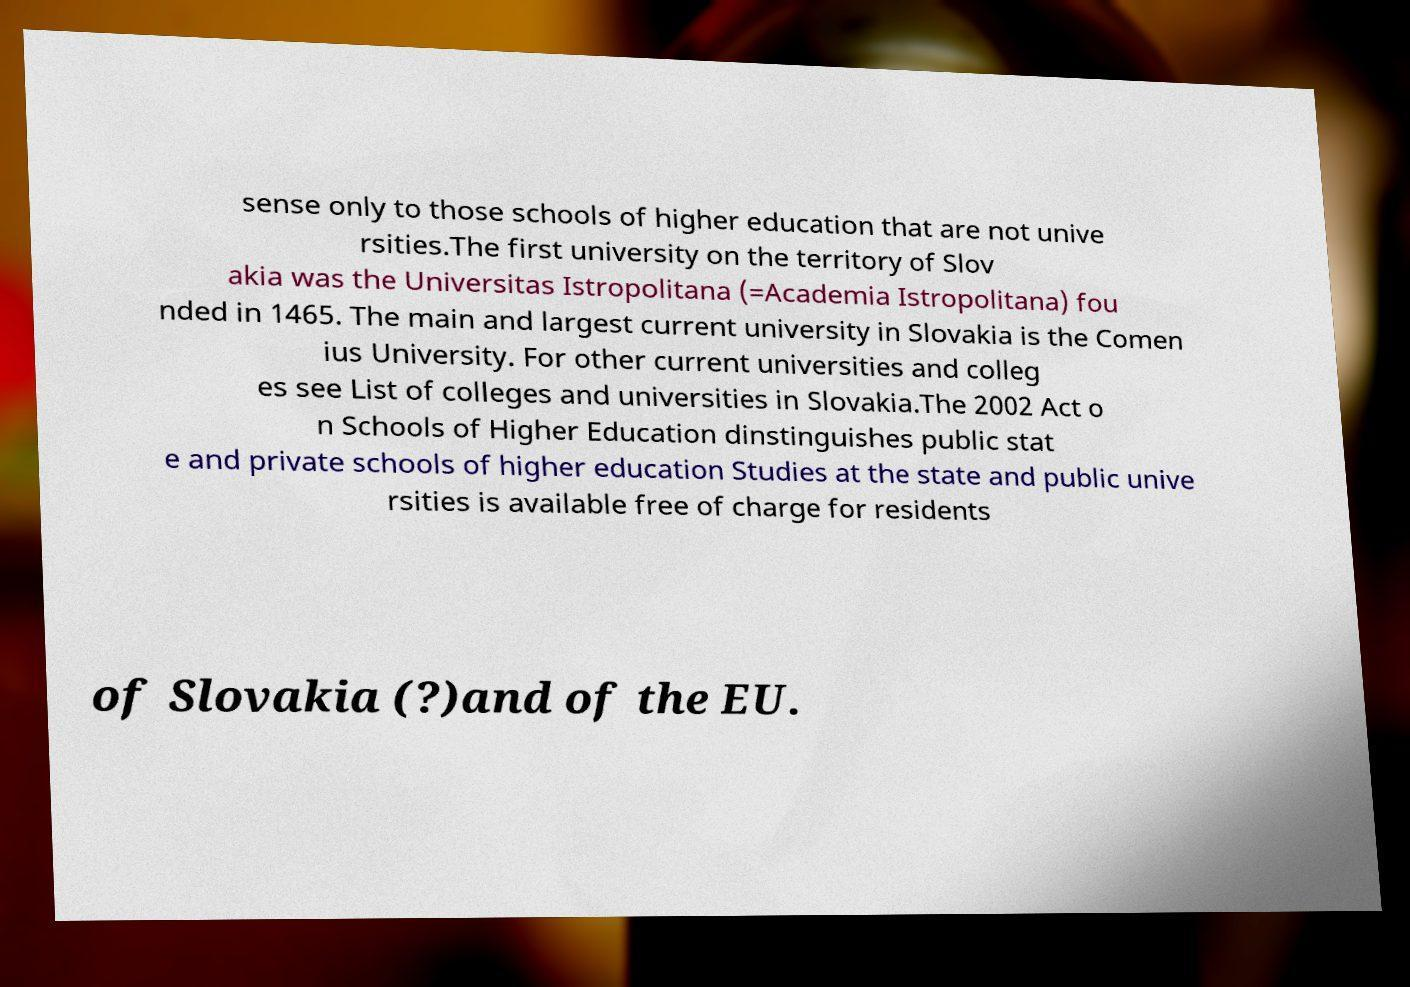Can you accurately transcribe the text from the provided image for me? sense only to those schools of higher education that are not unive rsities.The first university on the territory of Slov akia was the Universitas Istropolitana (=Academia Istropolitana) fou nded in 1465. The main and largest current university in Slovakia is the Comen ius University. For other current universities and colleg es see List of colleges and universities in Slovakia.The 2002 Act o n Schools of Higher Education dinstinguishes public stat e and private schools of higher education Studies at the state and public unive rsities is available free of charge for residents of Slovakia (?)and of the EU. 